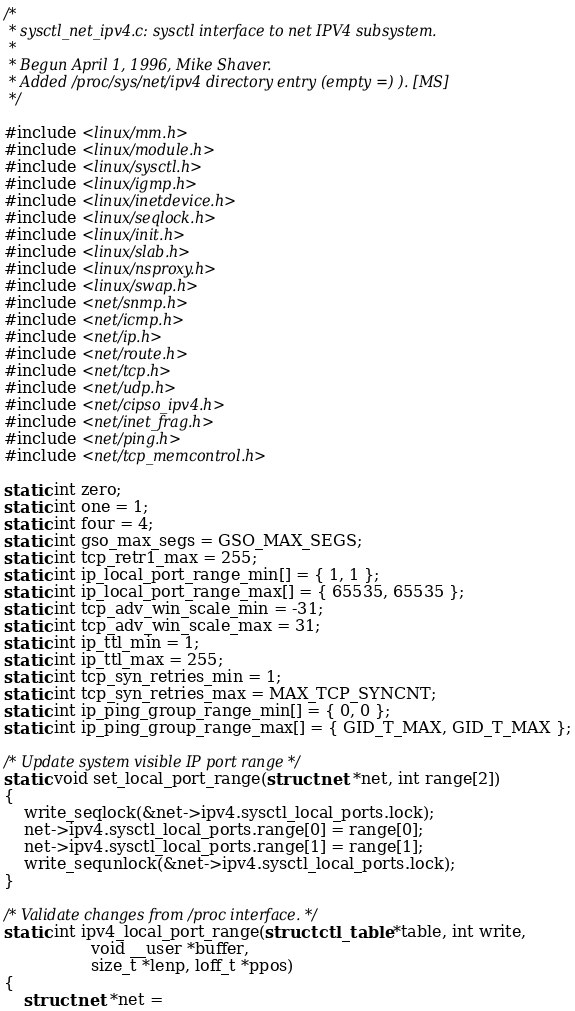<code> <loc_0><loc_0><loc_500><loc_500><_C_>/*
 * sysctl_net_ipv4.c: sysctl interface to net IPV4 subsystem.
 *
 * Begun April 1, 1996, Mike Shaver.
 * Added /proc/sys/net/ipv4 directory entry (empty =) ). [MS]
 */

#include <linux/mm.h>
#include <linux/module.h>
#include <linux/sysctl.h>
#include <linux/igmp.h>
#include <linux/inetdevice.h>
#include <linux/seqlock.h>
#include <linux/init.h>
#include <linux/slab.h>
#include <linux/nsproxy.h>
#include <linux/swap.h>
#include <net/snmp.h>
#include <net/icmp.h>
#include <net/ip.h>
#include <net/route.h>
#include <net/tcp.h>
#include <net/udp.h>
#include <net/cipso_ipv4.h>
#include <net/inet_frag.h>
#include <net/ping.h>
#include <net/tcp_memcontrol.h>

static int zero;
static int one = 1;
static int four = 4;
static int gso_max_segs = GSO_MAX_SEGS;
static int tcp_retr1_max = 255;
static int ip_local_port_range_min[] = { 1, 1 };
static int ip_local_port_range_max[] = { 65535, 65535 };
static int tcp_adv_win_scale_min = -31;
static int tcp_adv_win_scale_max = 31;
static int ip_ttl_min = 1;
static int ip_ttl_max = 255;
static int tcp_syn_retries_min = 1;
static int tcp_syn_retries_max = MAX_TCP_SYNCNT;
static int ip_ping_group_range_min[] = { 0, 0 };
static int ip_ping_group_range_max[] = { GID_T_MAX, GID_T_MAX };

/* Update system visible IP port range */
static void set_local_port_range(struct net *net, int range[2])
{
	write_seqlock(&net->ipv4.sysctl_local_ports.lock);
	net->ipv4.sysctl_local_ports.range[0] = range[0];
	net->ipv4.sysctl_local_ports.range[1] = range[1];
	write_sequnlock(&net->ipv4.sysctl_local_ports.lock);
}

/* Validate changes from /proc interface. */
static int ipv4_local_port_range(struct ctl_table *table, int write,
				 void __user *buffer,
				 size_t *lenp, loff_t *ppos)
{
	struct net *net =</code> 